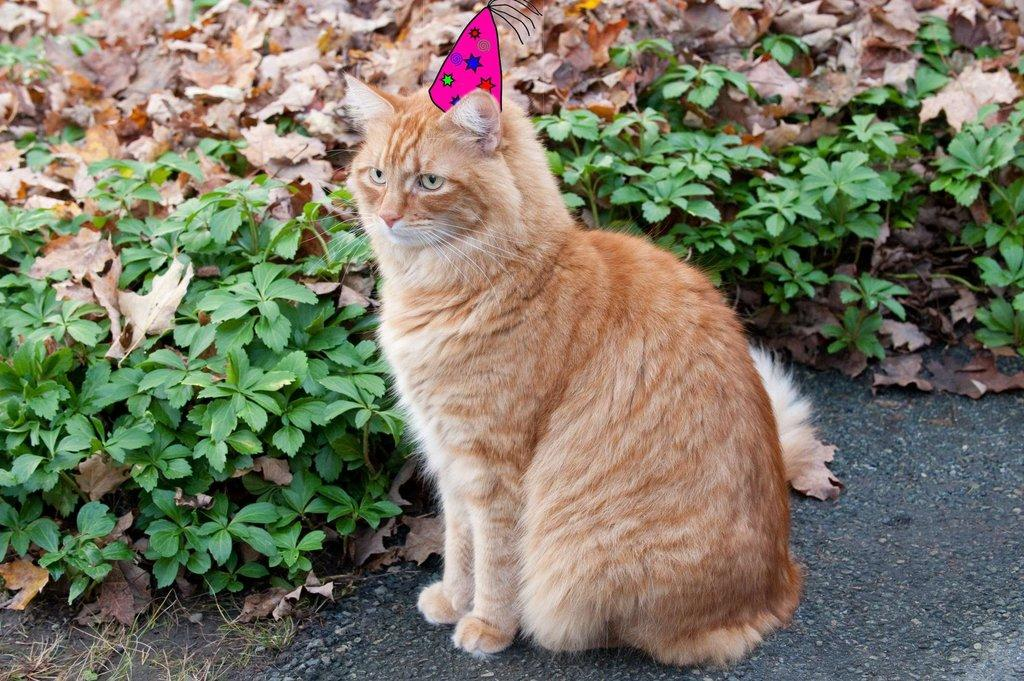What animal is in the front of the image? There is a cat in the front of the image. What type of vegetation can be seen in the background of the image? There are plants in the background of the image. What type of grain is being harvested in the image? There is no grain or harvesting activity present in the image; it features a cat and plants. What town is visible in the background of the image? There is no town visible in the image; it only features a cat and plants. 